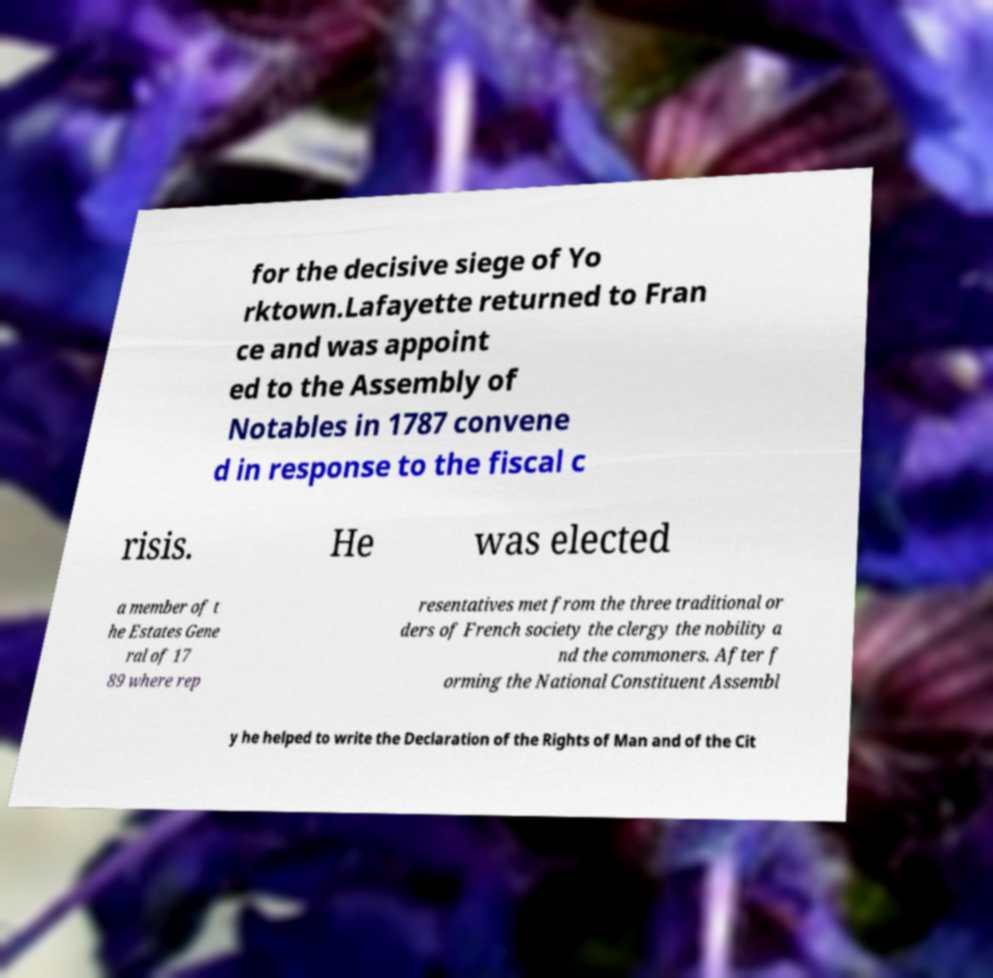Can you accurately transcribe the text from the provided image for me? for the decisive siege of Yo rktown.Lafayette returned to Fran ce and was appoint ed to the Assembly of Notables in 1787 convene d in response to the fiscal c risis. He was elected a member of t he Estates Gene ral of 17 89 where rep resentatives met from the three traditional or ders of French society the clergy the nobility a nd the commoners. After f orming the National Constituent Assembl y he helped to write the Declaration of the Rights of Man and of the Cit 